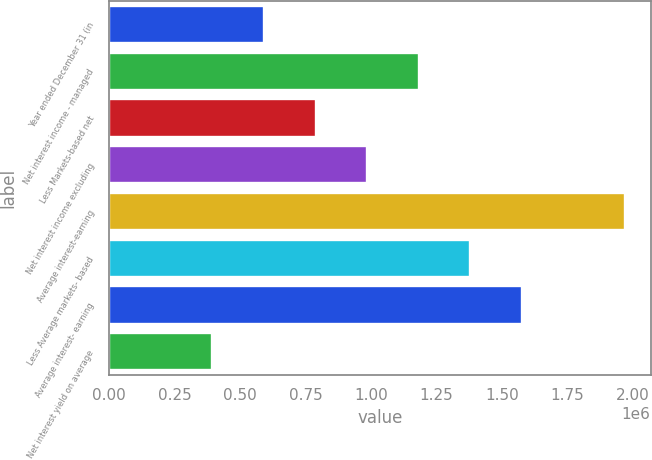<chart> <loc_0><loc_0><loc_500><loc_500><bar_chart><fcel>Year ended December 31 (in<fcel>Net interest income - managed<fcel>Less Markets-based net<fcel>Net interest income excluding<fcel>Average interest-earning<fcel>Less Average markets- based<fcel>Average interest- earning<fcel>Net interest yield on average<nl><fcel>591070<fcel>1.18214e+06<fcel>788093<fcel>985116<fcel>1.97023e+06<fcel>1.37916e+06<fcel>1.57619e+06<fcel>394047<nl></chart> 